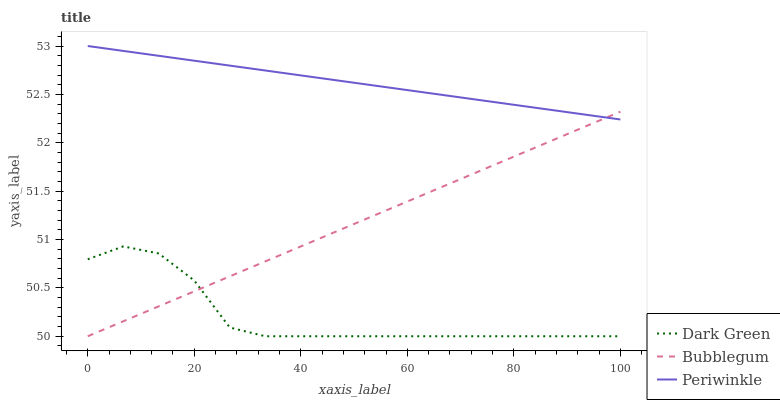Does Dark Green have the minimum area under the curve?
Answer yes or no. Yes. Does Periwinkle have the maximum area under the curve?
Answer yes or no. Yes. Does Bubblegum have the minimum area under the curve?
Answer yes or no. No. Does Bubblegum have the maximum area under the curve?
Answer yes or no. No. Is Periwinkle the smoothest?
Answer yes or no. Yes. Is Dark Green the roughest?
Answer yes or no. Yes. Is Bubblegum the smoothest?
Answer yes or no. No. Is Bubblegum the roughest?
Answer yes or no. No. Does Bubblegum have the lowest value?
Answer yes or no. Yes. Does Periwinkle have the highest value?
Answer yes or no. Yes. Does Bubblegum have the highest value?
Answer yes or no. No. Is Dark Green less than Periwinkle?
Answer yes or no. Yes. Is Periwinkle greater than Dark Green?
Answer yes or no. Yes. Does Bubblegum intersect Dark Green?
Answer yes or no. Yes. Is Bubblegum less than Dark Green?
Answer yes or no. No. Is Bubblegum greater than Dark Green?
Answer yes or no. No. Does Dark Green intersect Periwinkle?
Answer yes or no. No. 